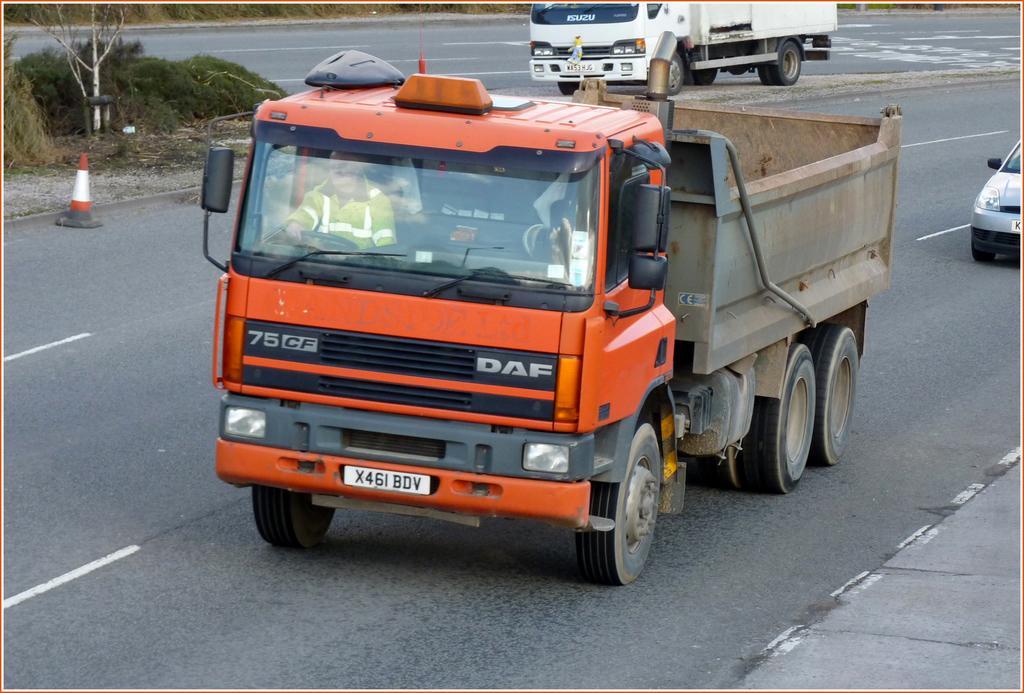Could you give a brief overview of what you see in this image? There are vehicles on the road and this is a traffic cone. Here we can see a person inside the vehicle and there are plants. 